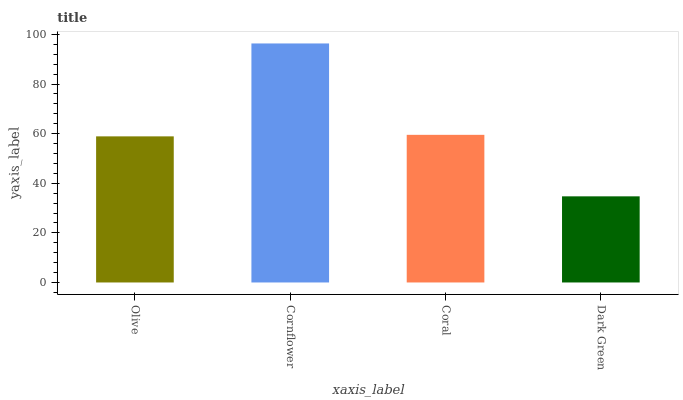Is Coral the minimum?
Answer yes or no. No. Is Coral the maximum?
Answer yes or no. No. Is Cornflower greater than Coral?
Answer yes or no. Yes. Is Coral less than Cornflower?
Answer yes or no. Yes. Is Coral greater than Cornflower?
Answer yes or no. No. Is Cornflower less than Coral?
Answer yes or no. No. Is Coral the high median?
Answer yes or no. Yes. Is Olive the low median?
Answer yes or no. Yes. Is Dark Green the high median?
Answer yes or no. No. Is Cornflower the low median?
Answer yes or no. No. 